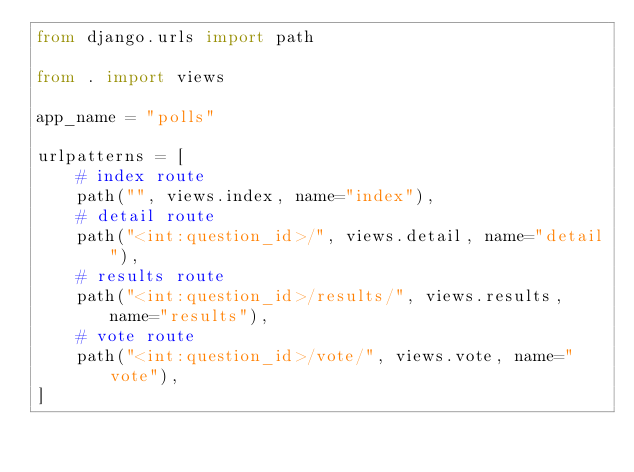Convert code to text. <code><loc_0><loc_0><loc_500><loc_500><_Python_>from django.urls import path

from . import views

app_name = "polls"

urlpatterns = [
    # index route
    path("", views.index, name="index"),
    # detail route
    path("<int:question_id>/", views.detail, name="detail"),
    # results route
    path("<int:question_id>/results/", views.results, name="results"),
    # vote route
    path("<int:question_id>/vote/", views.vote, name="vote"),
]
</code> 